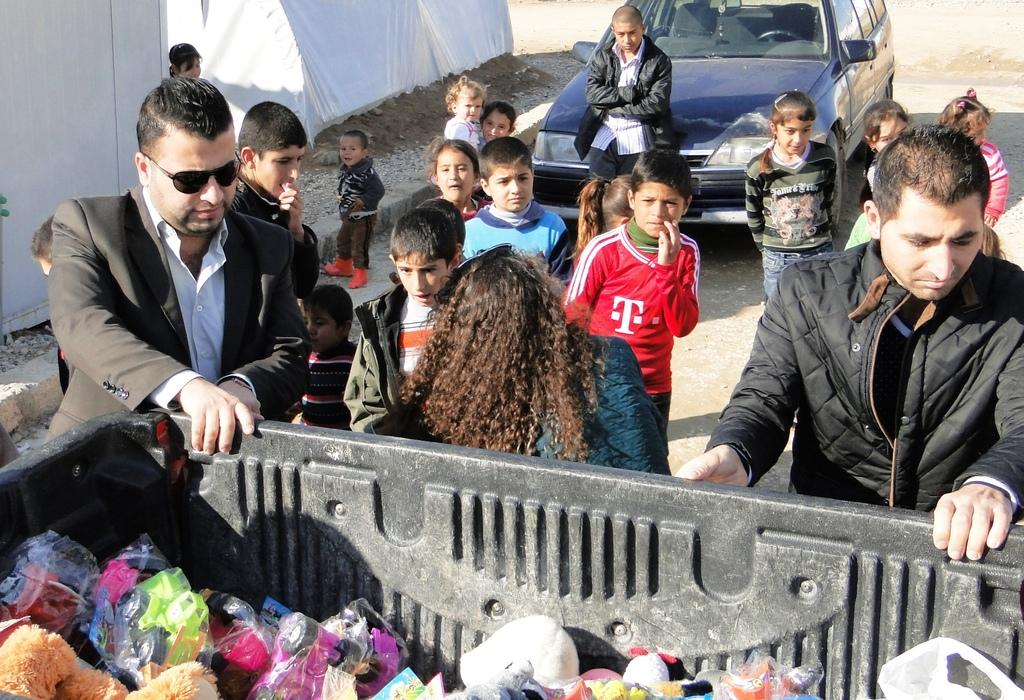What are the people in the image doing? The group of people is standing on the road. What else can be seen on the road besides the people? There is a car on the road. Are there any objects visible in the image that are not related to the people or the car? Yes, there are toys visible in the image. What type of structure can be seen in the image? There is a white tent in the image. What type of toe is visible in the image? There are no toes visible in the image. Is there a rainstorm occurring in the image? There is no indication of a rainstorm in the image. 